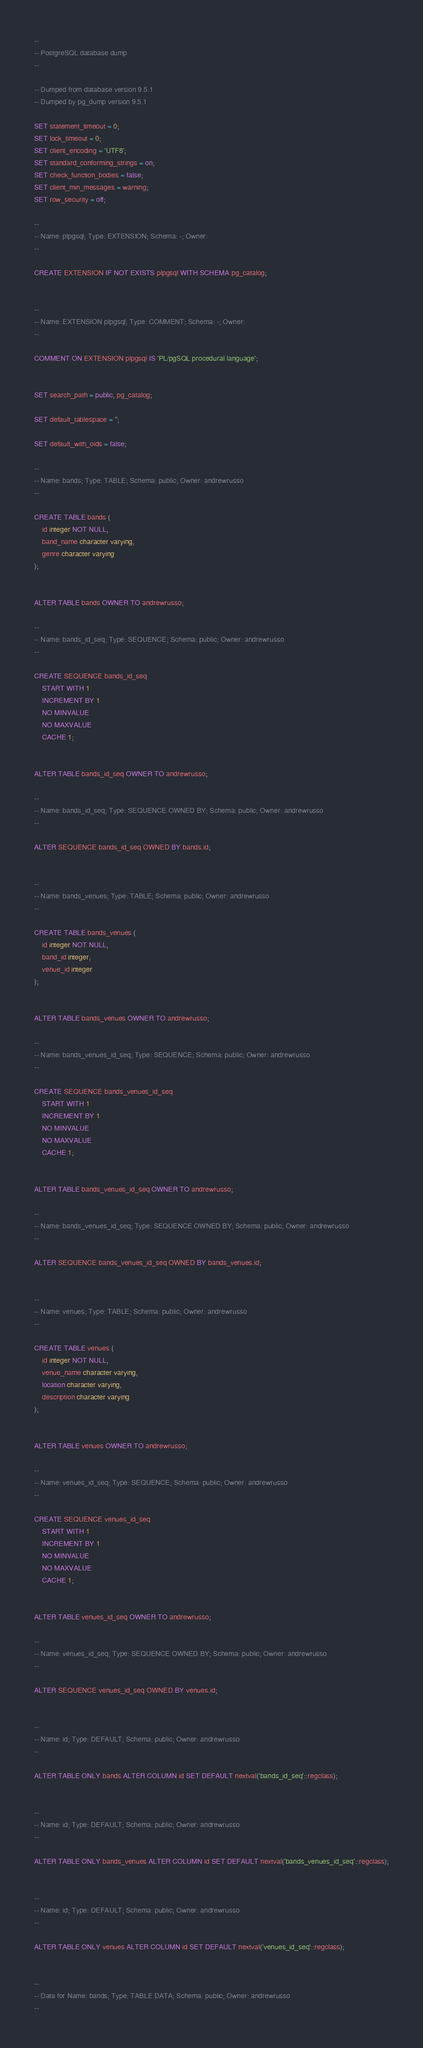<code> <loc_0><loc_0><loc_500><loc_500><_SQL_>--
-- PostgreSQL database dump
--

-- Dumped from database version 9.5.1
-- Dumped by pg_dump version 9.5.1

SET statement_timeout = 0;
SET lock_timeout = 0;
SET client_encoding = 'UTF8';
SET standard_conforming_strings = on;
SET check_function_bodies = false;
SET client_min_messages = warning;
SET row_security = off;

--
-- Name: plpgsql; Type: EXTENSION; Schema: -; Owner: 
--

CREATE EXTENSION IF NOT EXISTS plpgsql WITH SCHEMA pg_catalog;


--
-- Name: EXTENSION plpgsql; Type: COMMENT; Schema: -; Owner: 
--

COMMENT ON EXTENSION plpgsql IS 'PL/pgSQL procedural language';


SET search_path = public, pg_catalog;

SET default_tablespace = '';

SET default_with_oids = false;

--
-- Name: bands; Type: TABLE; Schema: public; Owner: andrewrusso
--

CREATE TABLE bands (
    id integer NOT NULL,
    band_name character varying,
    genre character varying
);


ALTER TABLE bands OWNER TO andrewrusso;

--
-- Name: bands_id_seq; Type: SEQUENCE; Schema: public; Owner: andrewrusso
--

CREATE SEQUENCE bands_id_seq
    START WITH 1
    INCREMENT BY 1
    NO MINVALUE
    NO MAXVALUE
    CACHE 1;


ALTER TABLE bands_id_seq OWNER TO andrewrusso;

--
-- Name: bands_id_seq; Type: SEQUENCE OWNED BY; Schema: public; Owner: andrewrusso
--

ALTER SEQUENCE bands_id_seq OWNED BY bands.id;


--
-- Name: bands_venues; Type: TABLE; Schema: public; Owner: andrewrusso
--

CREATE TABLE bands_venues (
    id integer NOT NULL,
    band_id integer,
    venue_id integer
);


ALTER TABLE bands_venues OWNER TO andrewrusso;

--
-- Name: bands_venues_id_seq; Type: SEQUENCE; Schema: public; Owner: andrewrusso
--

CREATE SEQUENCE bands_venues_id_seq
    START WITH 1
    INCREMENT BY 1
    NO MINVALUE
    NO MAXVALUE
    CACHE 1;


ALTER TABLE bands_venues_id_seq OWNER TO andrewrusso;

--
-- Name: bands_venues_id_seq; Type: SEQUENCE OWNED BY; Schema: public; Owner: andrewrusso
--

ALTER SEQUENCE bands_venues_id_seq OWNED BY bands_venues.id;


--
-- Name: venues; Type: TABLE; Schema: public; Owner: andrewrusso
--

CREATE TABLE venues (
    id integer NOT NULL,
    venue_name character varying,
    location character varying,
    description character varying
);


ALTER TABLE venues OWNER TO andrewrusso;

--
-- Name: venues_id_seq; Type: SEQUENCE; Schema: public; Owner: andrewrusso
--

CREATE SEQUENCE venues_id_seq
    START WITH 1
    INCREMENT BY 1
    NO MINVALUE
    NO MAXVALUE
    CACHE 1;


ALTER TABLE venues_id_seq OWNER TO andrewrusso;

--
-- Name: venues_id_seq; Type: SEQUENCE OWNED BY; Schema: public; Owner: andrewrusso
--

ALTER SEQUENCE venues_id_seq OWNED BY venues.id;


--
-- Name: id; Type: DEFAULT; Schema: public; Owner: andrewrusso
--

ALTER TABLE ONLY bands ALTER COLUMN id SET DEFAULT nextval('bands_id_seq'::regclass);


--
-- Name: id; Type: DEFAULT; Schema: public; Owner: andrewrusso
--

ALTER TABLE ONLY bands_venues ALTER COLUMN id SET DEFAULT nextval('bands_venues_id_seq'::regclass);


--
-- Name: id; Type: DEFAULT; Schema: public; Owner: andrewrusso
--

ALTER TABLE ONLY venues ALTER COLUMN id SET DEFAULT nextval('venues_id_seq'::regclass);


--
-- Data for Name: bands; Type: TABLE DATA; Schema: public; Owner: andrewrusso
--
</code> 